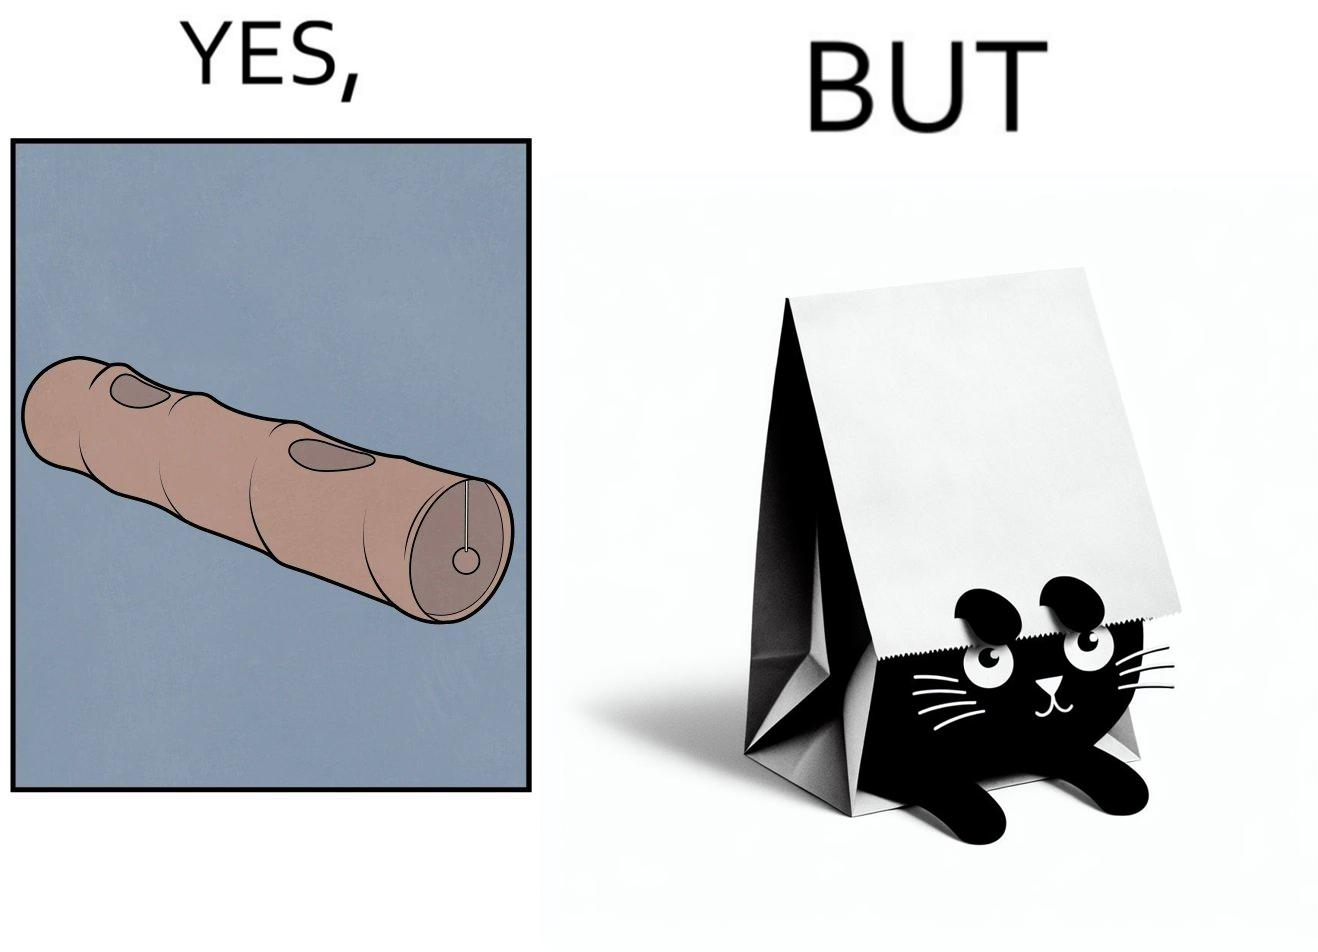Is this a satirical image? Yes, this image is satirical. 